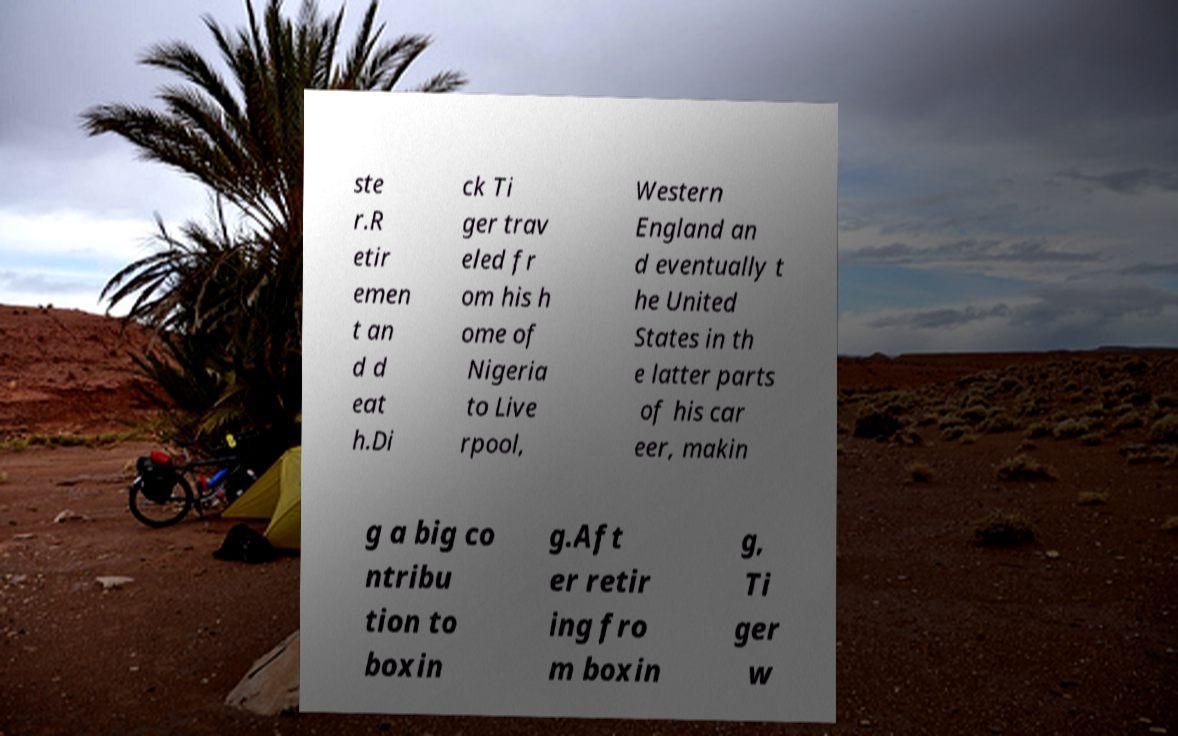What messages or text are displayed in this image? I need them in a readable, typed format. ste r.R etir emen t an d d eat h.Di ck Ti ger trav eled fr om his h ome of Nigeria to Live rpool, Western England an d eventually t he United States in th e latter parts of his car eer, makin g a big co ntribu tion to boxin g.Aft er retir ing fro m boxin g, Ti ger w 